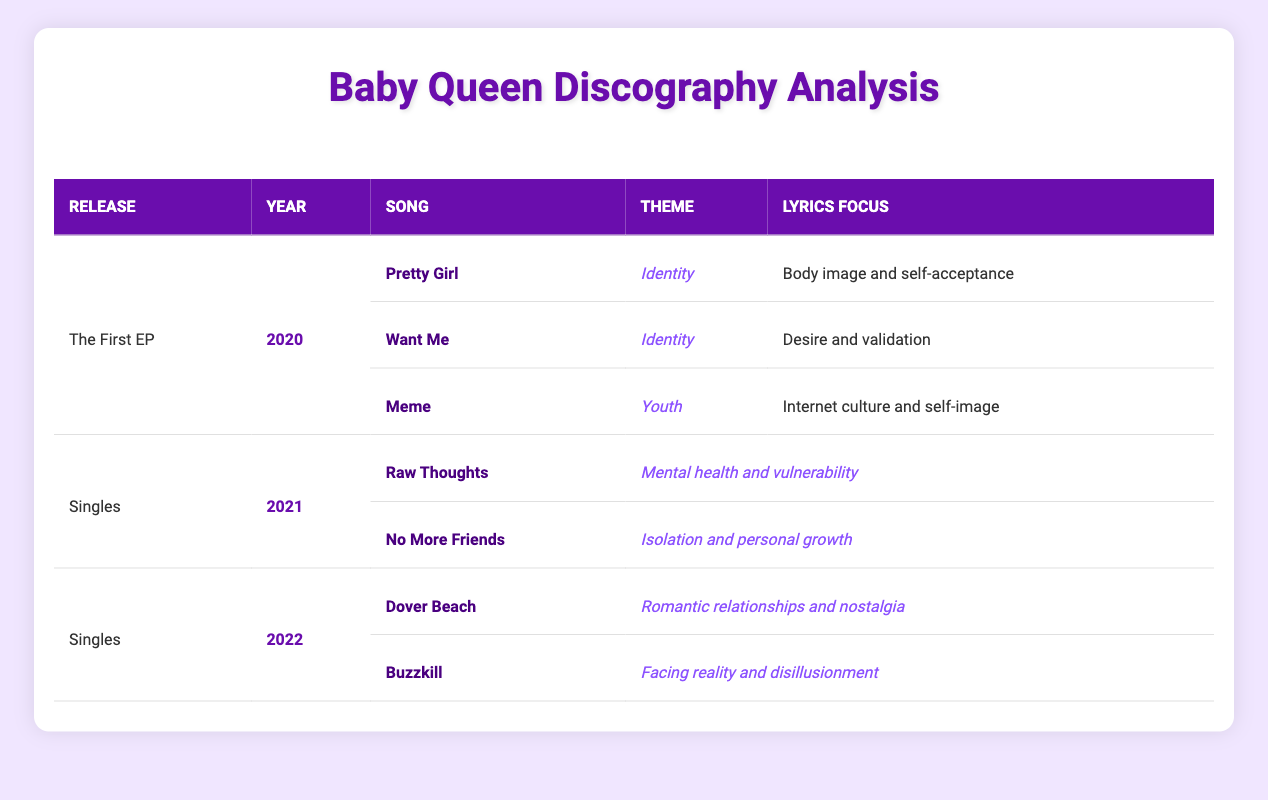What themes are represented in Baby Queen's first EP? The first EP contains the themes of Identity and Youth. Specifically, "Pretty Girl" and "Want Me" represent Identity, while "Meme" represents Youth.
Answer: Identity and Youth How many songs from the singles released in 2021 focus on mental health? Among the singles released in 2021, "Raw Thoughts" specifically focuses on mental health, while "No More Friends" relates to personal growth, making one song relevant to mental health.
Answer: 1 What is the lyrics focus of the song "Buzzkill"? The song "Buzzkill" focuses on the themes of facing reality and disillusionment, specifically highlighting the challenge of coming to terms with reality.
Answer: Facing reality and disillusionment Which song from the EP addresses body image? "Pretty Girl" from the EP addresses body image as a part of its lyrics focus on self-acceptance.
Answer: Pretty Girl How many songs discuss themes of identity across the entire discography? There are three songs that discuss themes of identity: "Pretty Girl" and "Want Me" from the EP, making a total of two songs focusing on identity, and "No More Friends" which discusses related themes of isolation linked to identity, making it three songs in total.
Answer: 3 Are there any songs from 2022 that focus on romantic relationships? Yes, "Dover Beach" from 2022 focuses on themes of romantic relationships and nostalgia.
Answer: Yes What is the total number of songs in Baby Queen's discography represented in the table? The total number of songs is the sum of songs from the EP, 2021 singles, and 2022 singles. The EP has three songs, 2021 singles has two songs, and 2022 singles has two songs, making it a total of 7 songs (3 + 2 + 2 = 7).
Answer: 7 What is the primary theme of the song "No More Friends"? The primary theme of "No More Friends" is isolation and personal growth.
Answer: Isolation and personal growth Which year features more singles by Baby Queen, 2021 or 2022? Both years feature the same number of singles: 2021 has two songs and 2022 also has two songs, making it equal.
Answer: They are equal 